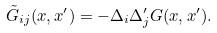Convert formula to latex. <formula><loc_0><loc_0><loc_500><loc_500>\tilde { G } _ { i j } ( x , x ^ { \prime } ) = - \Delta _ { i } \Delta _ { j } ^ { \prime } G ( x , x ^ { \prime } ) .</formula> 